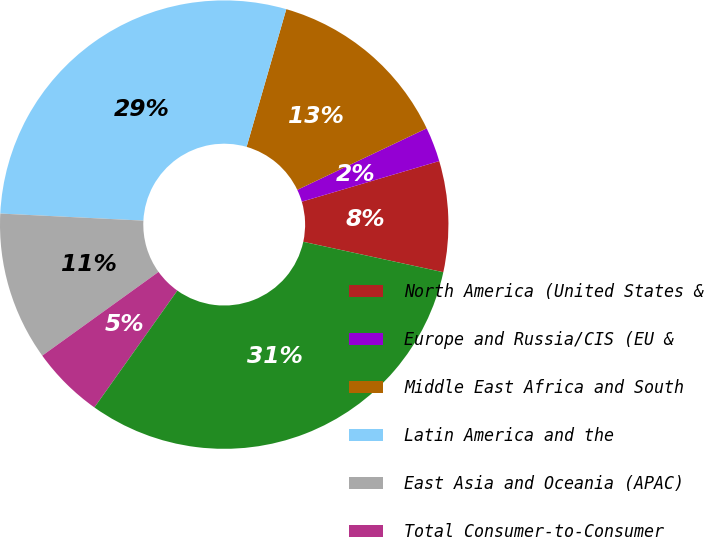Convert chart to OTSL. <chart><loc_0><loc_0><loc_500><loc_500><pie_chart><fcel>North America (United States &<fcel>Europe and Russia/CIS (EU &<fcel>Middle East Africa and South<fcel>Latin America and the<fcel>East Asia and Oceania (APAC)<fcel>Total Consumer-to-Consumer<fcel>westernunioncom (c)<nl><fcel>7.98%<fcel>2.49%<fcel>13.47%<fcel>28.68%<fcel>10.72%<fcel>5.24%<fcel>31.42%<nl></chart> 